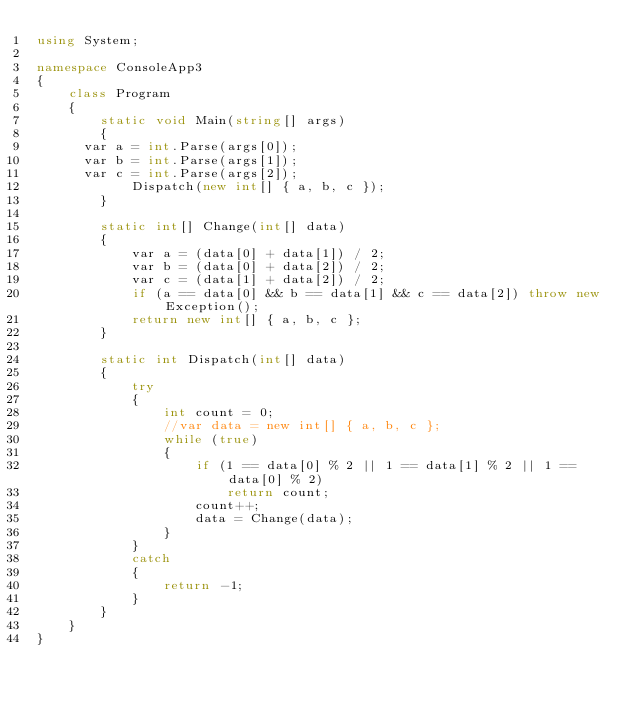<code> <loc_0><loc_0><loc_500><loc_500><_C#_>using System;

namespace ConsoleApp3
{
    class Program
    {
        static void Main(string[] args)
        {
			var a = int.Parse(args[0]);
			var b = int.Parse(args[1]);
			var c = int.Parse(args[2]);
            Dispatch(new int[] { a, b, c });
        }

        static int[] Change(int[] data)
        {
            var a = (data[0] + data[1]) / 2;
            var b = (data[0] + data[2]) / 2;
            var c = (data[1] + data[2]) / 2;
            if (a == data[0] && b == data[1] && c == data[2]) throw new Exception();
            return new int[] { a, b, c };
        }

        static int Dispatch(int[] data)
        {
            try
            {
                int count = 0;
                //var data = new int[] { a, b, c };
                while (true)
                {
                    if (1 == data[0] % 2 || 1 == data[1] % 2 || 1 == data[0] % 2)
                        return count;
                    count++;
                    data = Change(data);
                }
            }
            catch
            {
                return -1;
            }
        }
    }
}
</code> 